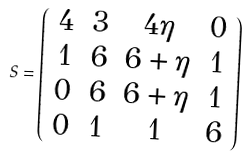<formula> <loc_0><loc_0><loc_500><loc_500>S = \left ( \begin{array} { c c c c } 4 & 3 & 4 \eta & 0 \\ 1 & 6 & 6 + \eta & 1 \\ 0 & 6 & 6 + \eta & 1 \\ 0 & 1 & 1 & 6 \\ \end{array} \right )</formula> 